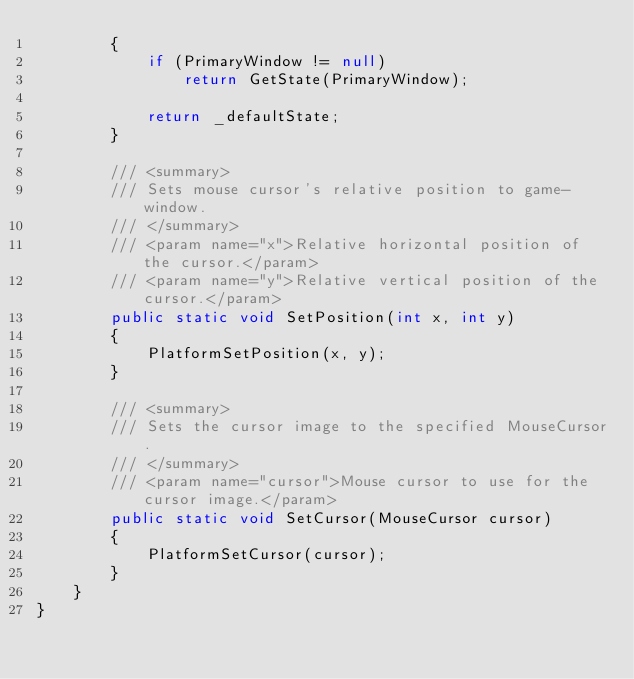Convert code to text. <code><loc_0><loc_0><loc_500><loc_500><_C#_>        {
            if (PrimaryWindow != null)
                return GetState(PrimaryWindow);

            return _defaultState;
        }

        /// <summary>
        /// Sets mouse cursor's relative position to game-window.
        /// </summary>
        /// <param name="x">Relative horizontal position of the cursor.</param>
        /// <param name="y">Relative vertical position of the cursor.</param>
        public static void SetPosition(int x, int y)
        {
            PlatformSetPosition(x, y);
        }

        /// <summary>
        /// Sets the cursor image to the specified MouseCursor.
        /// </summary>
        /// <param name="cursor">Mouse cursor to use for the cursor image.</param>
        public static void SetCursor(MouseCursor cursor)
        {
            PlatformSetCursor(cursor);
        }
    }
}
</code> 